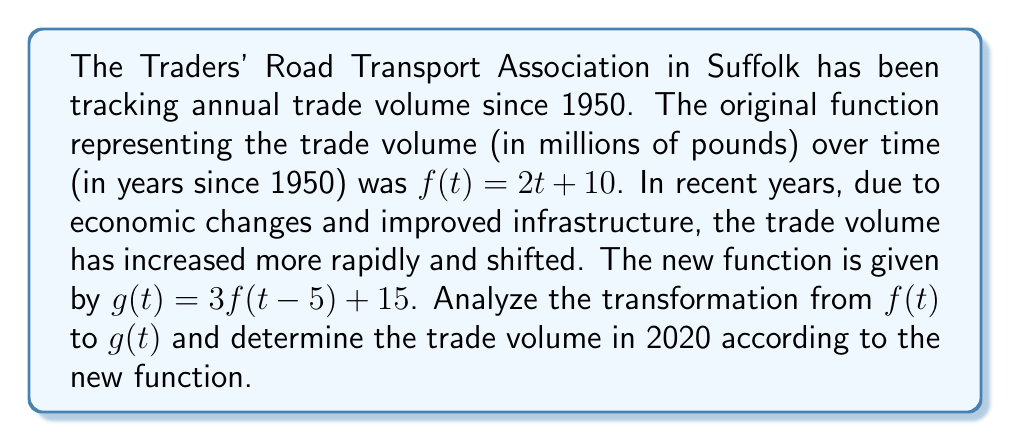Provide a solution to this math problem. To analyze the transformation from $f(t)$ to $g(t)$ and find the trade volume in 2020, let's follow these steps:

1) First, let's break down the transformation from $f(t)$ to $g(t)$:
   $g(t) = 3f(t-5) + 15$

   This involves three transformations:
   a) A horizontal shift of 5 units right: $f(t-5)$
   b) A vertical stretch by a factor of 3: $3f(t-5)$
   c) A vertical shift of 15 units up: $3f(t-5) + 15$

2) Let's apply these transformations to the original function $f(t) = 2t + 10$:
   $g(t) = 3[2(t-5) + 10] + 15$
   $g(t) = 3[2t - 10 + 10] + 15$
   $g(t) = 3[2t] + 15$
   $g(t) = 6t + 15$

3) Now that we have the new function, we can calculate the trade volume in 2020.
   2020 is 70 years after 1950, so we need to find $g(70)$:

   $g(70) = 6(70) + 15$
   $g(70) = 420 + 15$
   $g(70) = 435$

Therefore, according to the new function, the trade volume in 2020 would be 435 million pounds.
Answer: The transformation from $f(t)$ to $g(t)$ involves a horizontal shift of 5 units right, a vertical stretch by a factor of 3, and a vertical shift of 15 units up. The resulting function is $g(t) = 6t + 15$. The trade volume in 2020, according to the new function, is 435 million pounds. 